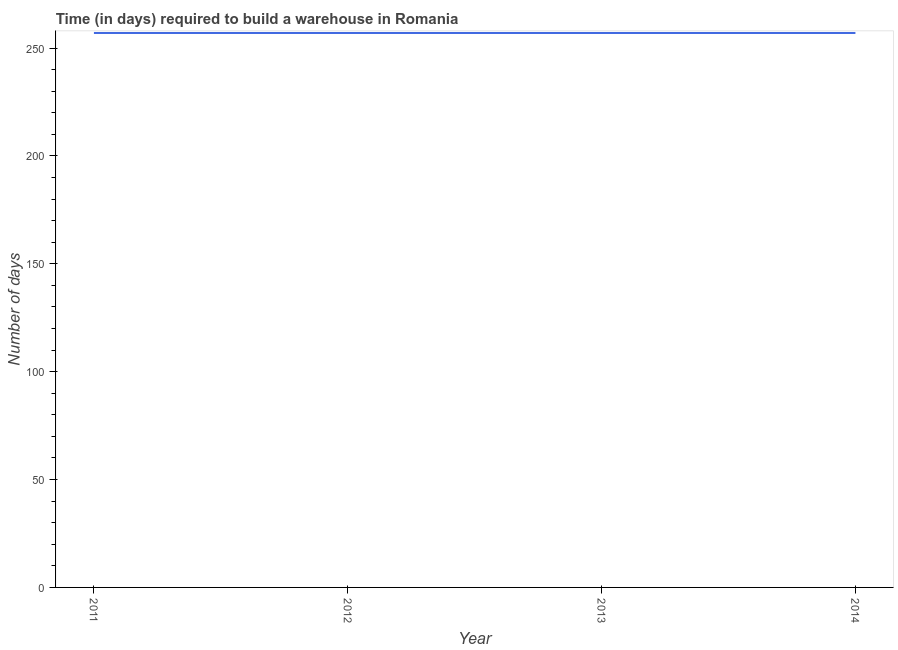What is the time required to build a warehouse in 2012?
Make the answer very short. 257. Across all years, what is the maximum time required to build a warehouse?
Offer a very short reply. 257. Across all years, what is the minimum time required to build a warehouse?
Offer a very short reply. 257. What is the sum of the time required to build a warehouse?
Offer a very short reply. 1028. What is the difference between the time required to build a warehouse in 2011 and 2012?
Provide a short and direct response. 0. What is the average time required to build a warehouse per year?
Keep it short and to the point. 257. What is the median time required to build a warehouse?
Ensure brevity in your answer.  257. In how many years, is the time required to build a warehouse greater than 150 days?
Your response must be concise. 4. Is the difference between the time required to build a warehouse in 2011 and 2012 greater than the difference between any two years?
Make the answer very short. Yes. What is the difference between the highest and the lowest time required to build a warehouse?
Offer a very short reply. 0. Does the time required to build a warehouse monotonically increase over the years?
Offer a very short reply. No. Are the values on the major ticks of Y-axis written in scientific E-notation?
Provide a succinct answer. No. What is the title of the graph?
Provide a short and direct response. Time (in days) required to build a warehouse in Romania. What is the label or title of the X-axis?
Keep it short and to the point. Year. What is the label or title of the Y-axis?
Provide a short and direct response. Number of days. What is the Number of days of 2011?
Your response must be concise. 257. What is the Number of days of 2012?
Provide a succinct answer. 257. What is the Number of days of 2013?
Ensure brevity in your answer.  257. What is the Number of days of 2014?
Ensure brevity in your answer.  257. What is the difference between the Number of days in 2011 and 2012?
Provide a short and direct response. 0. What is the difference between the Number of days in 2011 and 2013?
Offer a terse response. 0. What is the difference between the Number of days in 2011 and 2014?
Your response must be concise. 0. What is the difference between the Number of days in 2012 and 2014?
Offer a terse response. 0. What is the ratio of the Number of days in 2011 to that in 2013?
Provide a succinct answer. 1. What is the ratio of the Number of days in 2012 to that in 2013?
Your response must be concise. 1. What is the ratio of the Number of days in 2013 to that in 2014?
Keep it short and to the point. 1. 